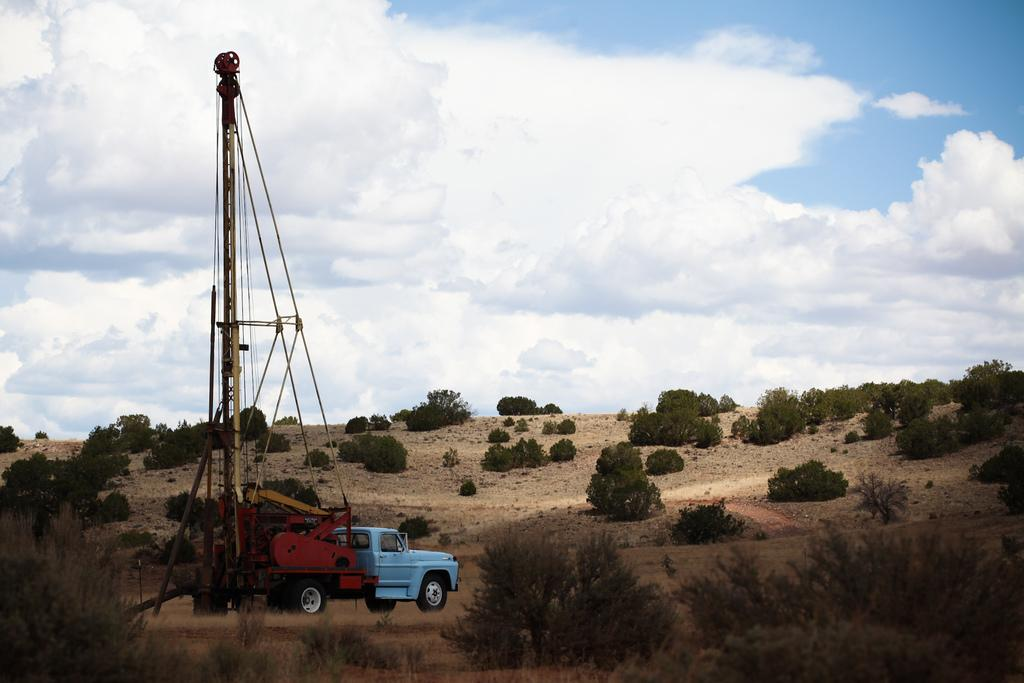What type of vehicle is in the image? The facts do not specify the type of vehicle, but there is a vehicle present in the image. What else can be seen in the image besides the vehicle? There are poles, sand, plants, and the sky visible in the image. What is the terrain like in the image? The terrain appears to be sandy, as indicated by the presence of sand at the bottom of the image. What type of vegetation is present in the image? There are plants in the image. What type of box can be seen in the image? There is no box present in the image. 